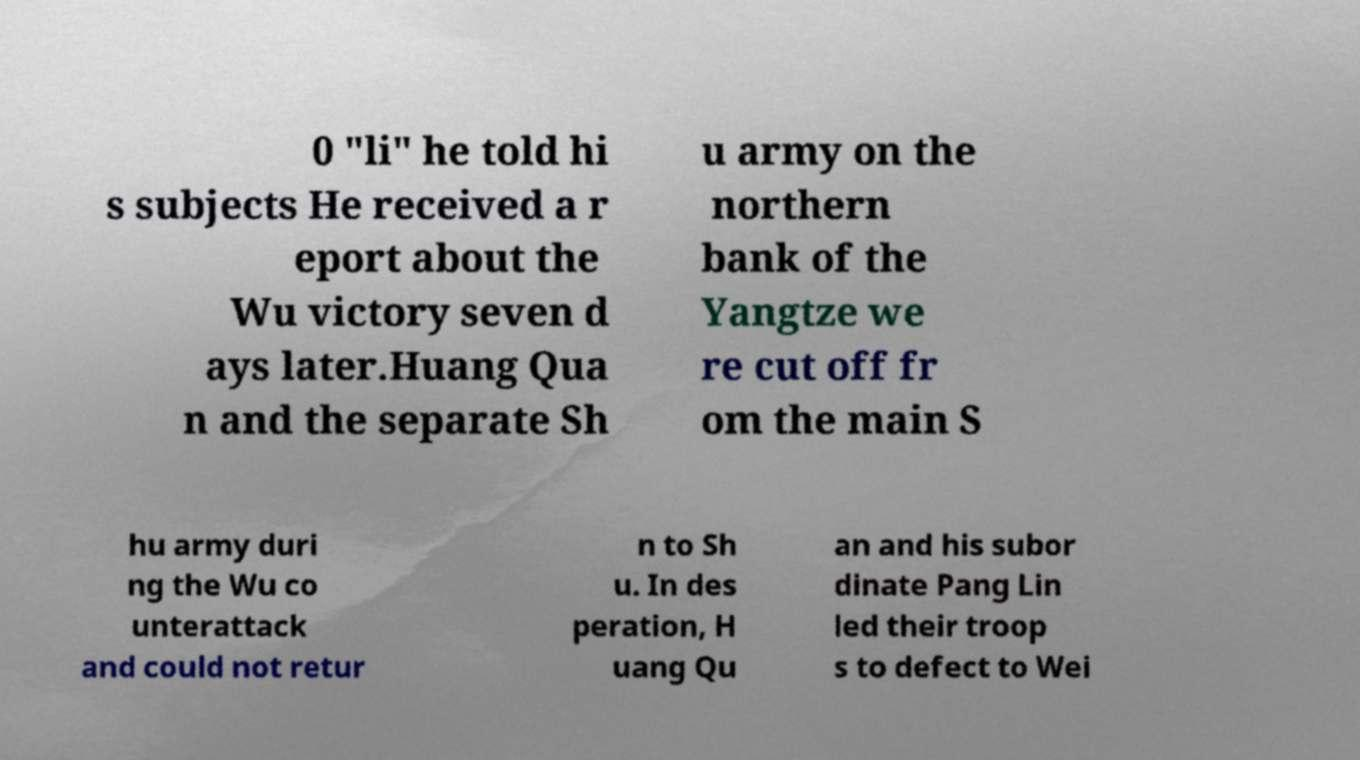What messages or text are displayed in this image? I need them in a readable, typed format. 0 "li" he told hi s subjects He received a r eport about the Wu victory seven d ays later.Huang Qua n and the separate Sh u army on the northern bank of the Yangtze we re cut off fr om the main S hu army duri ng the Wu co unterattack and could not retur n to Sh u. In des peration, H uang Qu an and his subor dinate Pang Lin led their troop s to defect to Wei 